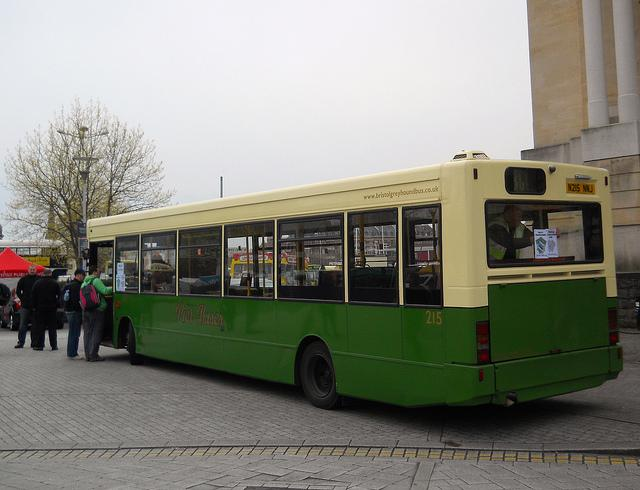In which country is this bus taking on passengers?

Choices:
A) japan
B) england
C) united states
D) fiji england 